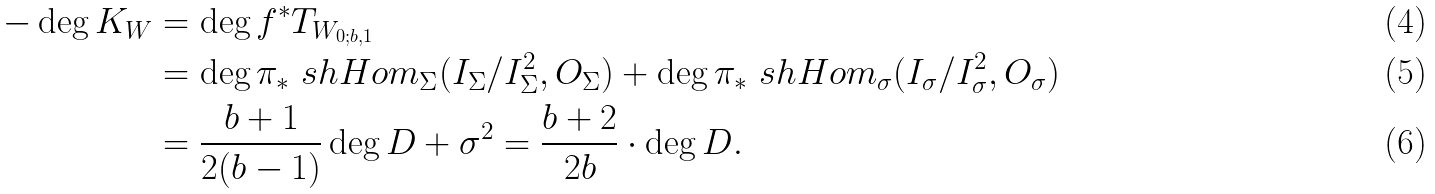Convert formula to latex. <formula><loc_0><loc_0><loc_500><loc_500>- \deg K _ { W } & = \deg f ^ { * } T _ { W _ { 0 ; b , 1 } } \\ & = \deg \pi _ { * } \ s h H o m _ { \Sigma } ( I _ { \Sigma } / I _ { \Sigma } ^ { 2 } , O _ { \Sigma } ) + \deg \pi _ { * } \ s h H o m _ { \sigma } ( I _ { \sigma } / I _ { \sigma } ^ { 2 } , O _ { \sigma } ) \\ & = \frac { b + 1 } { 2 ( b - 1 ) } \deg D + \sigma ^ { 2 } = \frac { b + 2 } { 2 b } \cdot \deg D .</formula> 